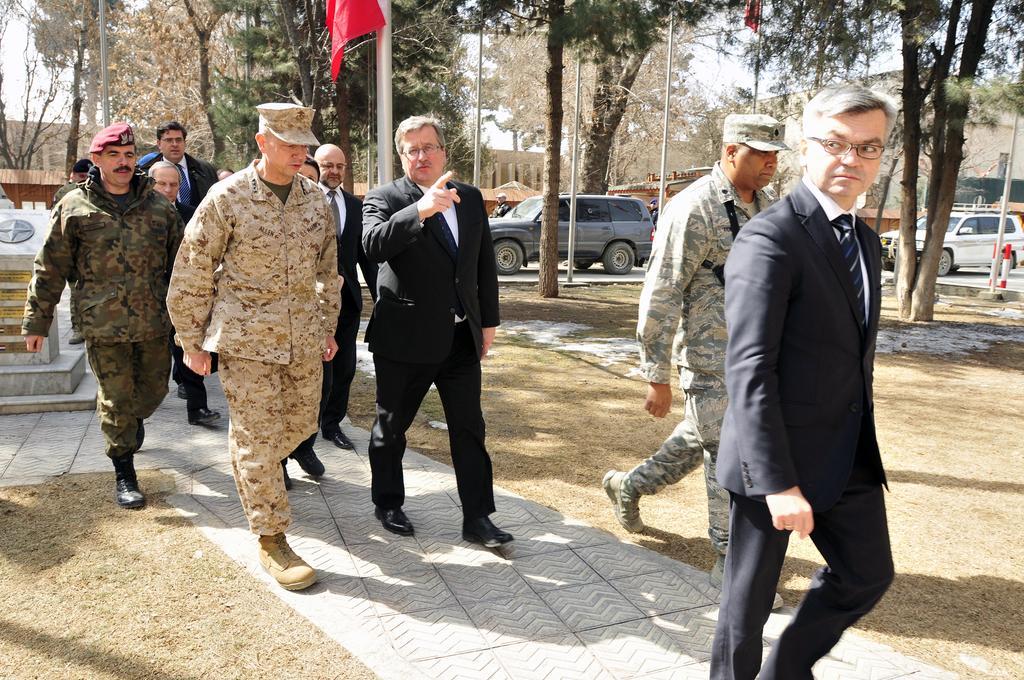In one or two sentences, can you explain what this image depicts? In this picture there are group of people walking. At the back there are vehicles on the road and there are buildings and trees and flags. At the top there is sky. At the bottom there is a pavement and there is grass. On the left side of the image there is a logo and there are boards on the wall. 